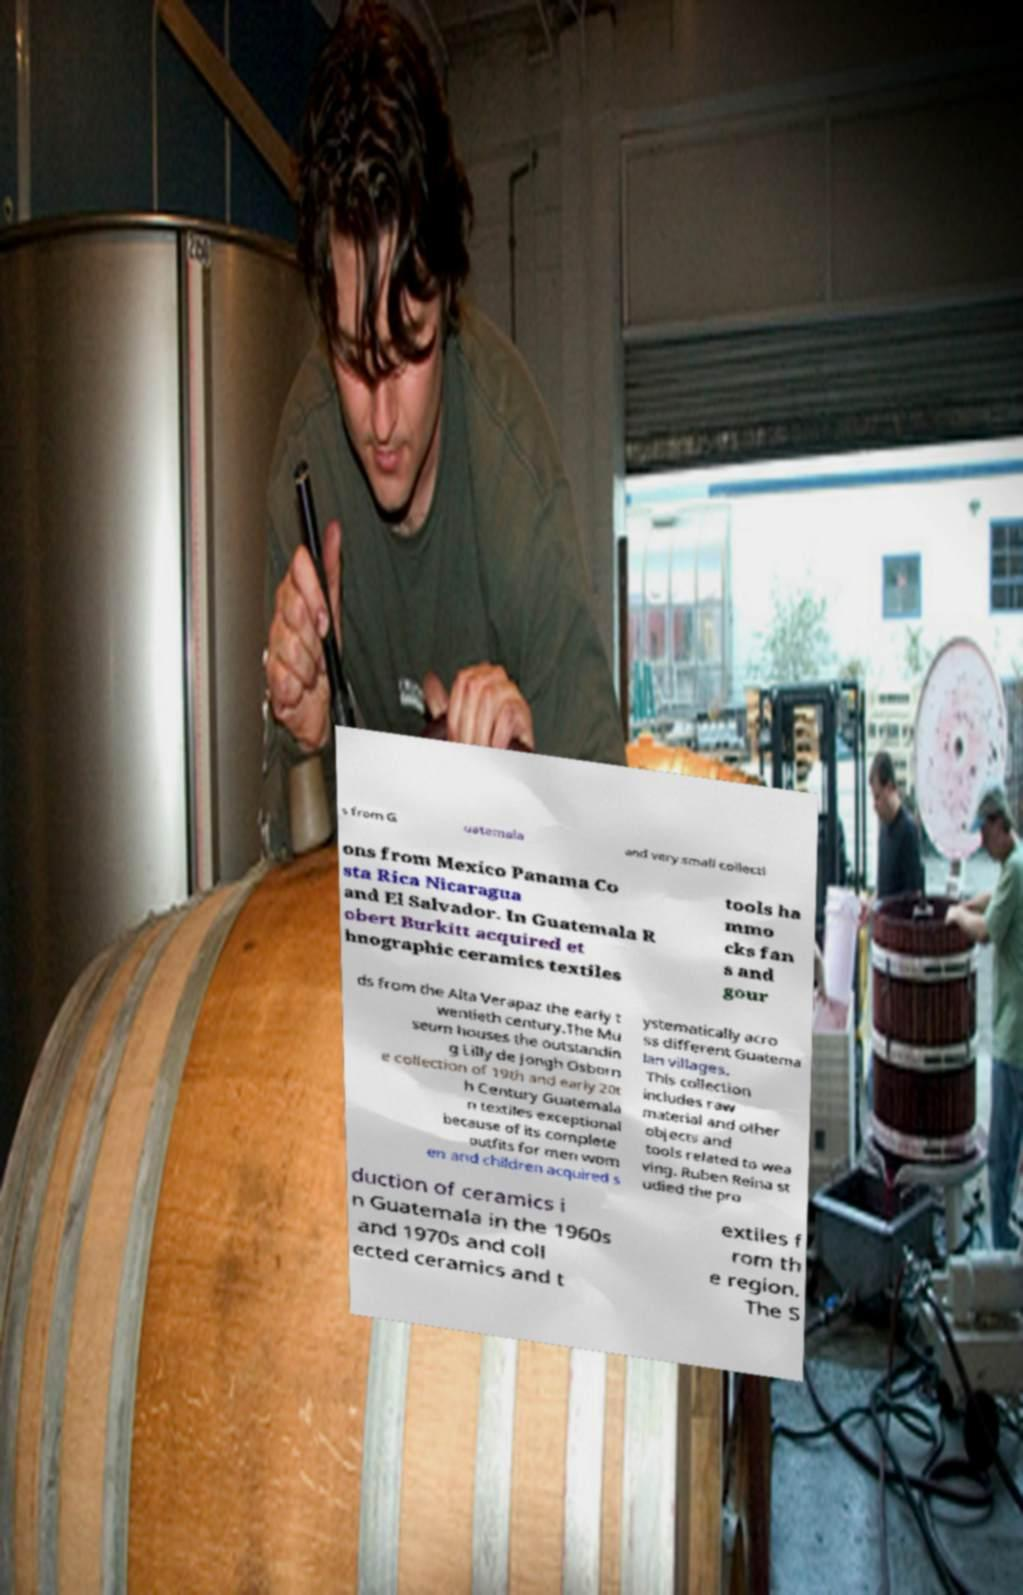What messages or text are displayed in this image? I need them in a readable, typed format. s from G uatemala and very small collecti ons from Mexico Panama Co sta Rica Nicaragua and El Salvador. In Guatemala R obert Burkitt acquired et hnographic ceramics textiles tools ha mmo cks fan s and gour ds from the Alta Verapaz the early t wentieth century.The Mu seum houses the outstandin g Lilly de Jongh Osborn e collection of 19th and early 20t h Century Guatemala n textiles exceptional because of its complete outfits for men wom en and children acquired s ystematically acro ss different Guatema lan villages. This collection includes raw material and other objects and tools related to wea ving. Ruben Reina st udied the pro duction of ceramics i n Guatemala in the 1960s and 1970s and coll ected ceramics and t extiles f rom th e region. The S 